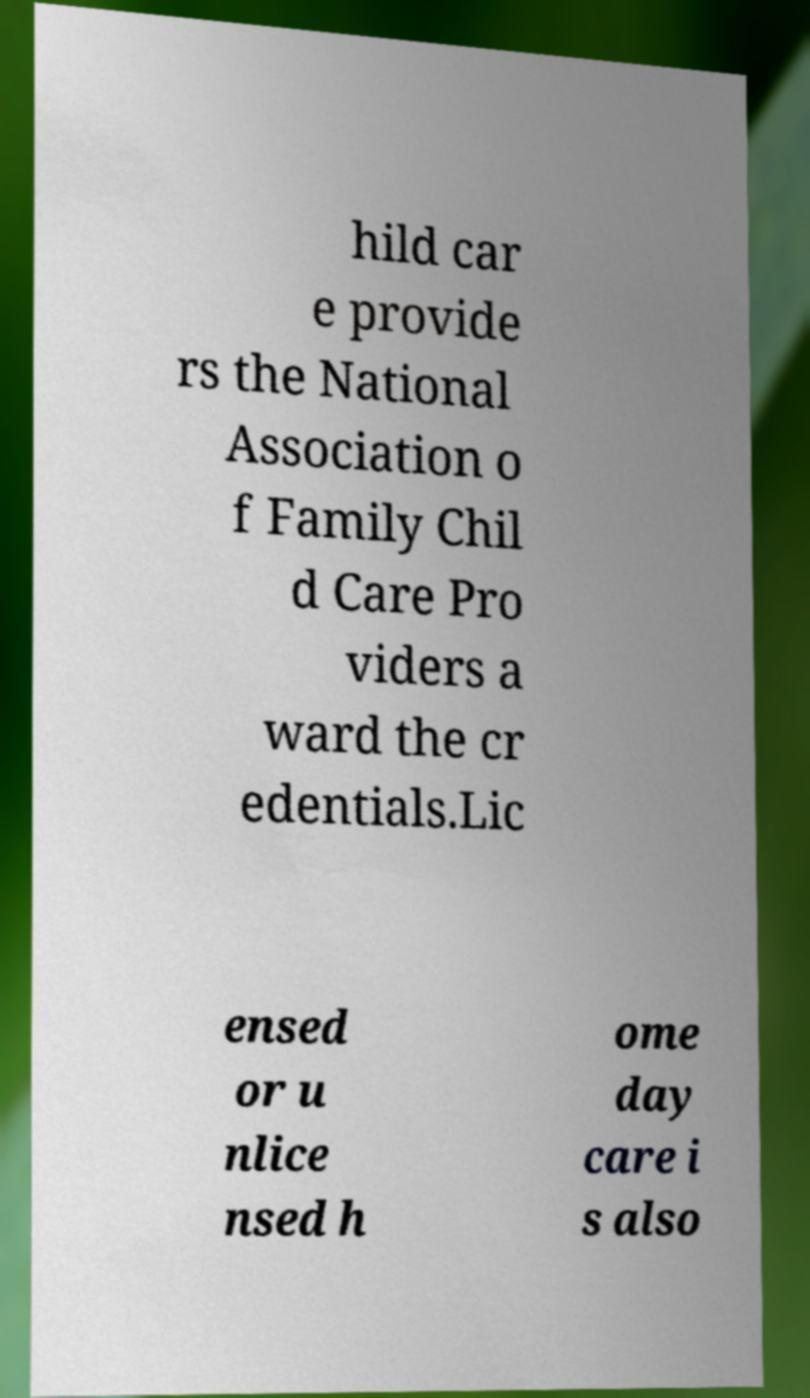Can you read and provide the text displayed in the image?This photo seems to have some interesting text. Can you extract and type it out for me? hild car e provide rs the National Association o f Family Chil d Care Pro viders a ward the cr edentials.Lic ensed or u nlice nsed h ome day care i s also 